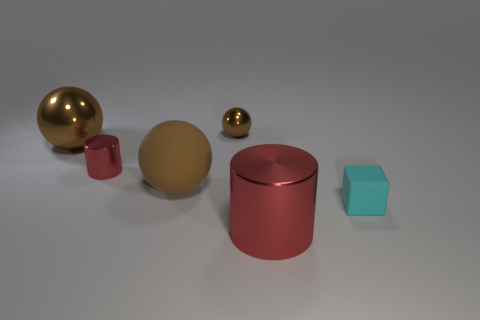Are there any red metal things of the same shape as the small cyan object?
Provide a short and direct response. No. The red metallic object that is the same size as the cyan rubber cube is what shape?
Your response must be concise. Cylinder. What is the tiny cyan cube made of?
Ensure brevity in your answer.  Rubber. There is a brown metal object to the left of the metallic thing that is behind the big metal thing that is to the left of the big red object; how big is it?
Keep it short and to the point. Large. There is another big sphere that is the same color as the rubber ball; what is its material?
Ensure brevity in your answer.  Metal. How many shiny things are either small red things or big objects?
Your response must be concise. 3. What size is the cyan rubber cube?
Offer a terse response. Small. What number of things are small cyan shiny spheres or brown metal things left of the tiny brown object?
Your response must be concise. 1. What number of other objects are there of the same color as the large metallic ball?
Offer a terse response. 2. Does the cyan object have the same size as the red object in front of the small matte object?
Give a very brief answer. No. 